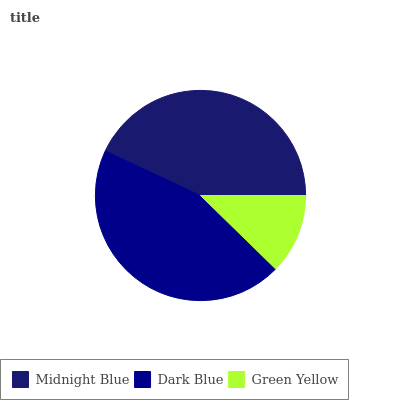Is Green Yellow the minimum?
Answer yes or no. Yes. Is Dark Blue the maximum?
Answer yes or no. Yes. Is Dark Blue the minimum?
Answer yes or no. No. Is Green Yellow the maximum?
Answer yes or no. No. Is Dark Blue greater than Green Yellow?
Answer yes or no. Yes. Is Green Yellow less than Dark Blue?
Answer yes or no. Yes. Is Green Yellow greater than Dark Blue?
Answer yes or no. No. Is Dark Blue less than Green Yellow?
Answer yes or no. No. Is Midnight Blue the high median?
Answer yes or no. Yes. Is Midnight Blue the low median?
Answer yes or no. Yes. Is Dark Blue the high median?
Answer yes or no. No. Is Dark Blue the low median?
Answer yes or no. No. 